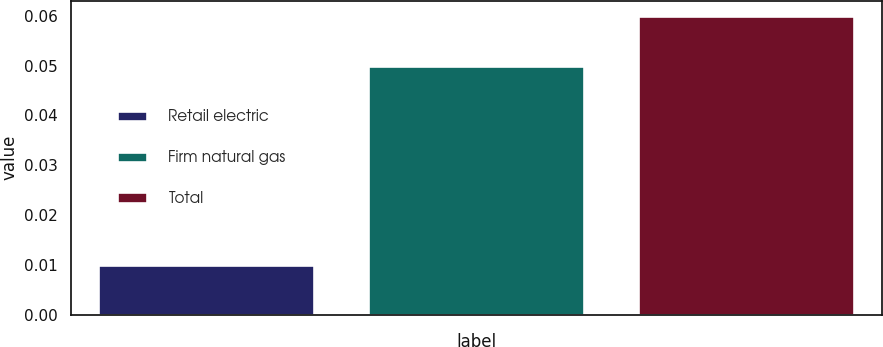Convert chart to OTSL. <chart><loc_0><loc_0><loc_500><loc_500><bar_chart><fcel>Retail electric<fcel>Firm natural gas<fcel>Total<nl><fcel>0.01<fcel>0.05<fcel>0.06<nl></chart> 